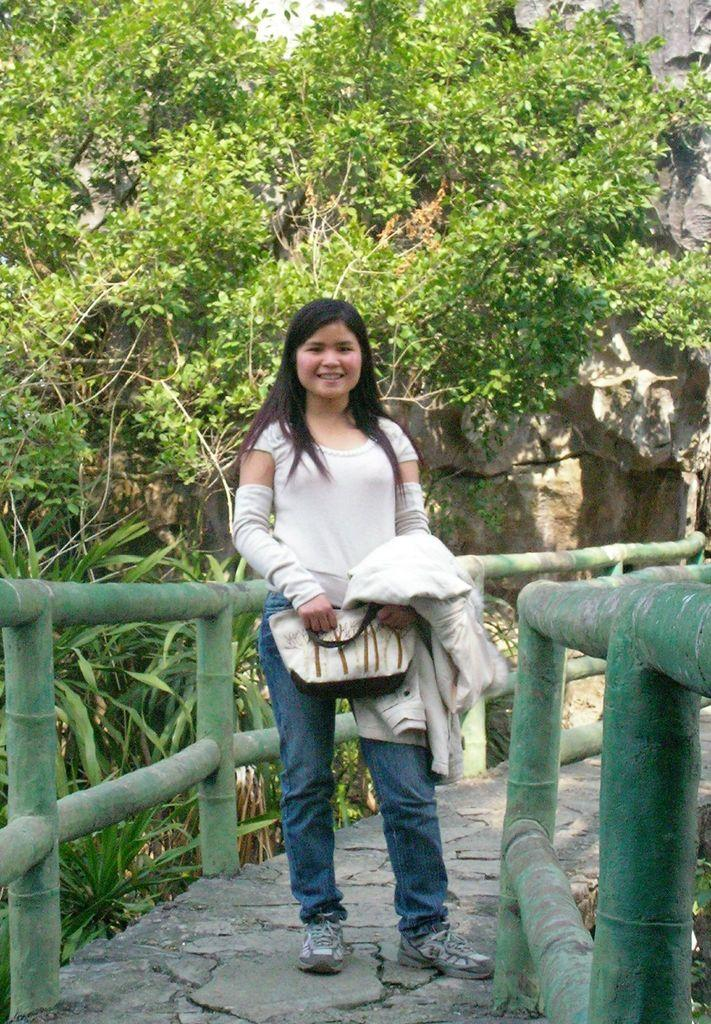Who is the main subject in the image? There is a girl in the image. What is the girl wearing? The girl is wearing a white dress and jeans. Where is the girl standing? The girl is standing on a bridge. What can be seen behind the girl? There are trees and plants behind the girl. What is in front of the girl? There is a mountain in front of the girl. What type of lunch is the girl eating in the image? There is no lunch present in the image; the girl is standing on a bridge with a mountain in front of her. 